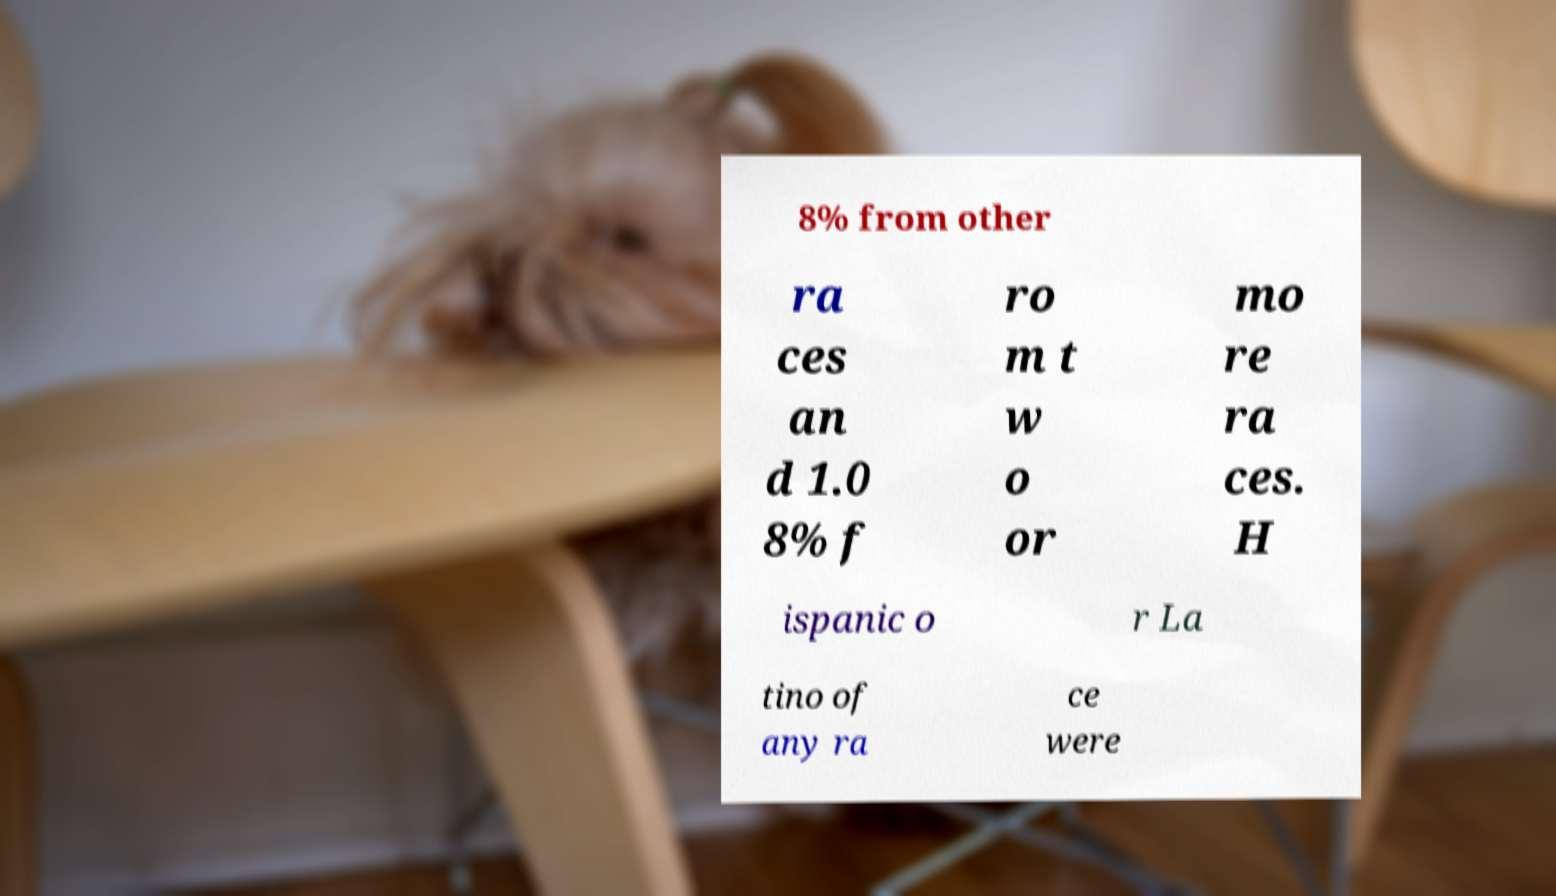Can you accurately transcribe the text from the provided image for me? 8% from other ra ces an d 1.0 8% f ro m t w o or mo re ra ces. H ispanic o r La tino of any ra ce were 